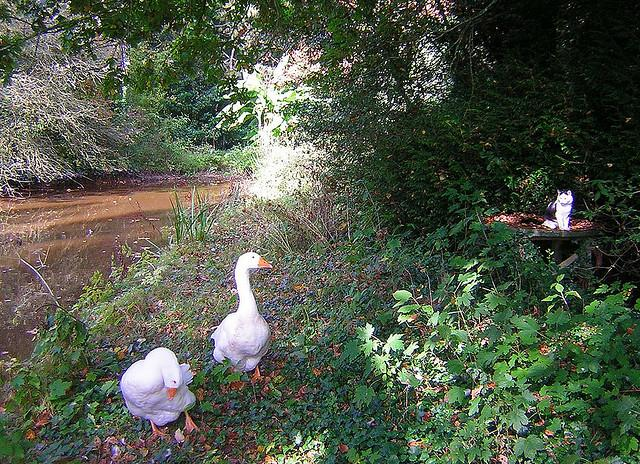Where is the cat staring to? geese 